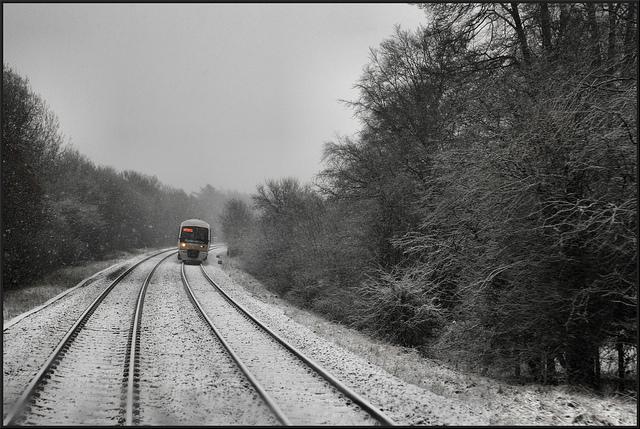What is the weather like?
Short answer required. Snowy. Do you see a shadow?
Concise answer only. No. How many trains are on the tracks?
Give a very brief answer. 1. What is covering the tracks?
Write a very short answer. Snow. Is there a semi?
Keep it brief. No. 